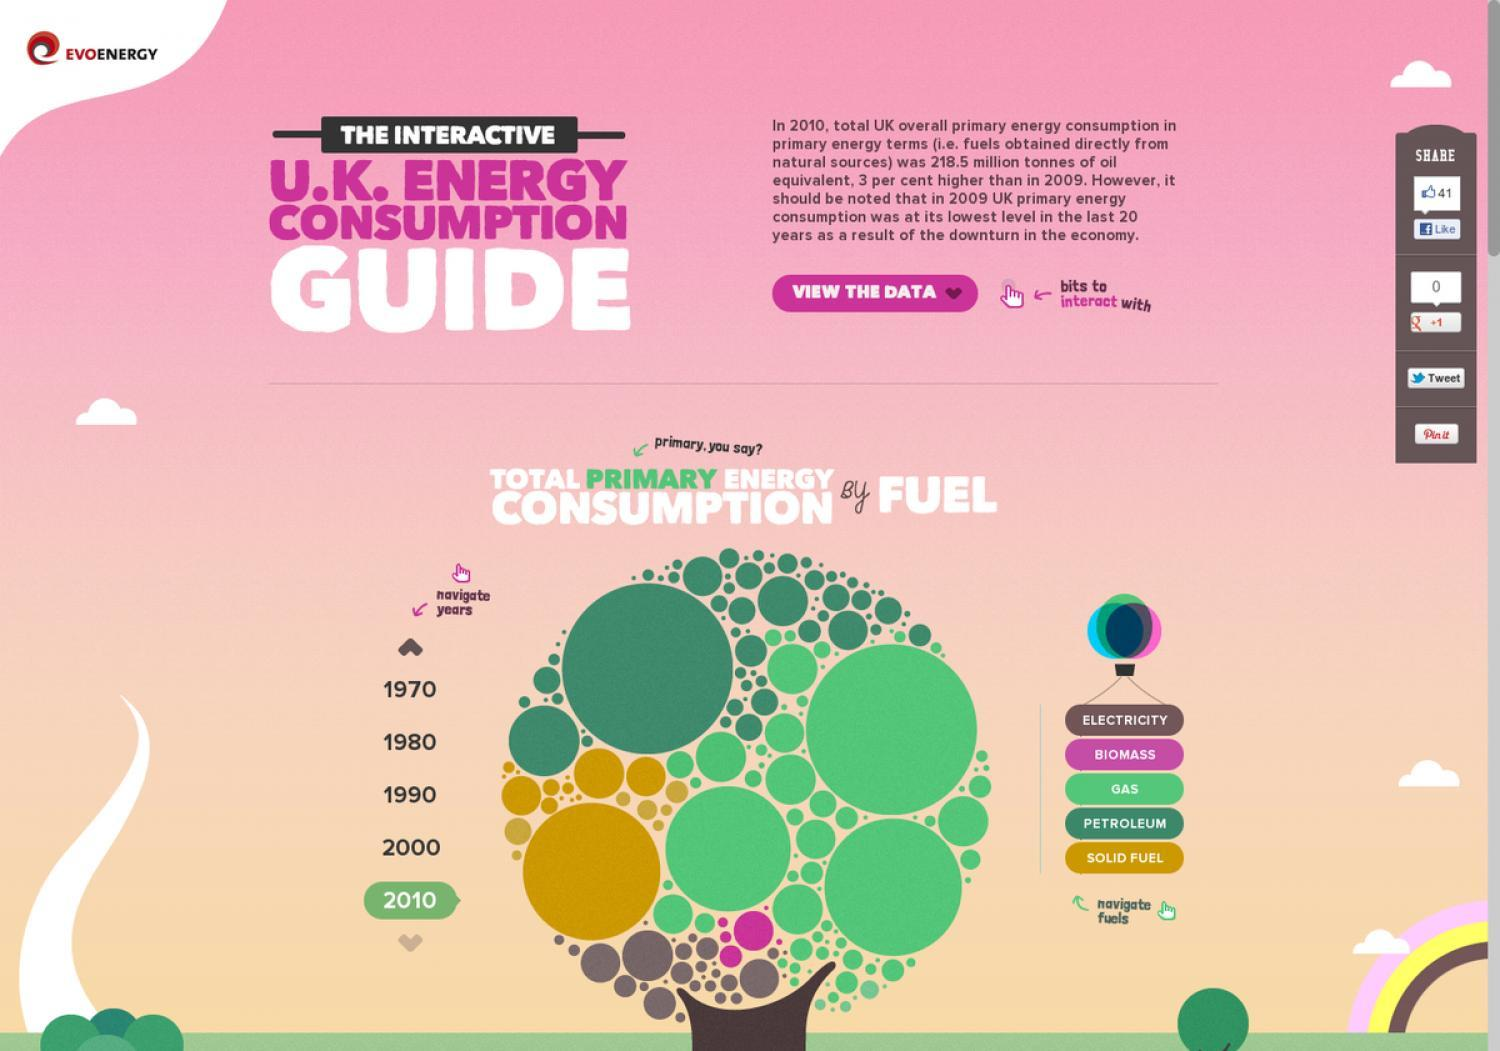Which is the third fuel in the list?
Answer the question with a short phrase. gas Which is the fourth fuel in the list? petroleum Which fuel is represented by pink color? biomass Which year is given in the middle of the list? 1990 which year is highlighted in the list of years on the left side of the tree? 2010 Which year is given fourth in the list? 2000 In what color the text "view the data" is written - white, pink or blue? white how many different kind of fuels are there in the graphics? 5 what is the number of cloud vector icons in this infographic? 4 In what color the word "guide" is written - white, pink or blue? white 